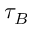Convert formula to latex. <formula><loc_0><loc_0><loc_500><loc_500>\tau _ { B }</formula> 